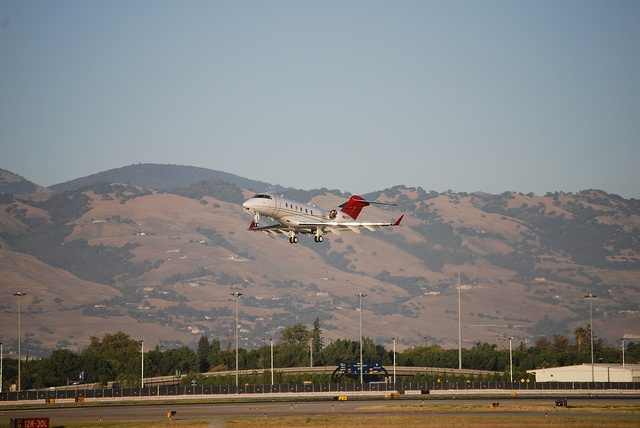Describe the objects in this image and their specific colors. I can see a airplane in gray, darkgray, and tan tones in this image. 